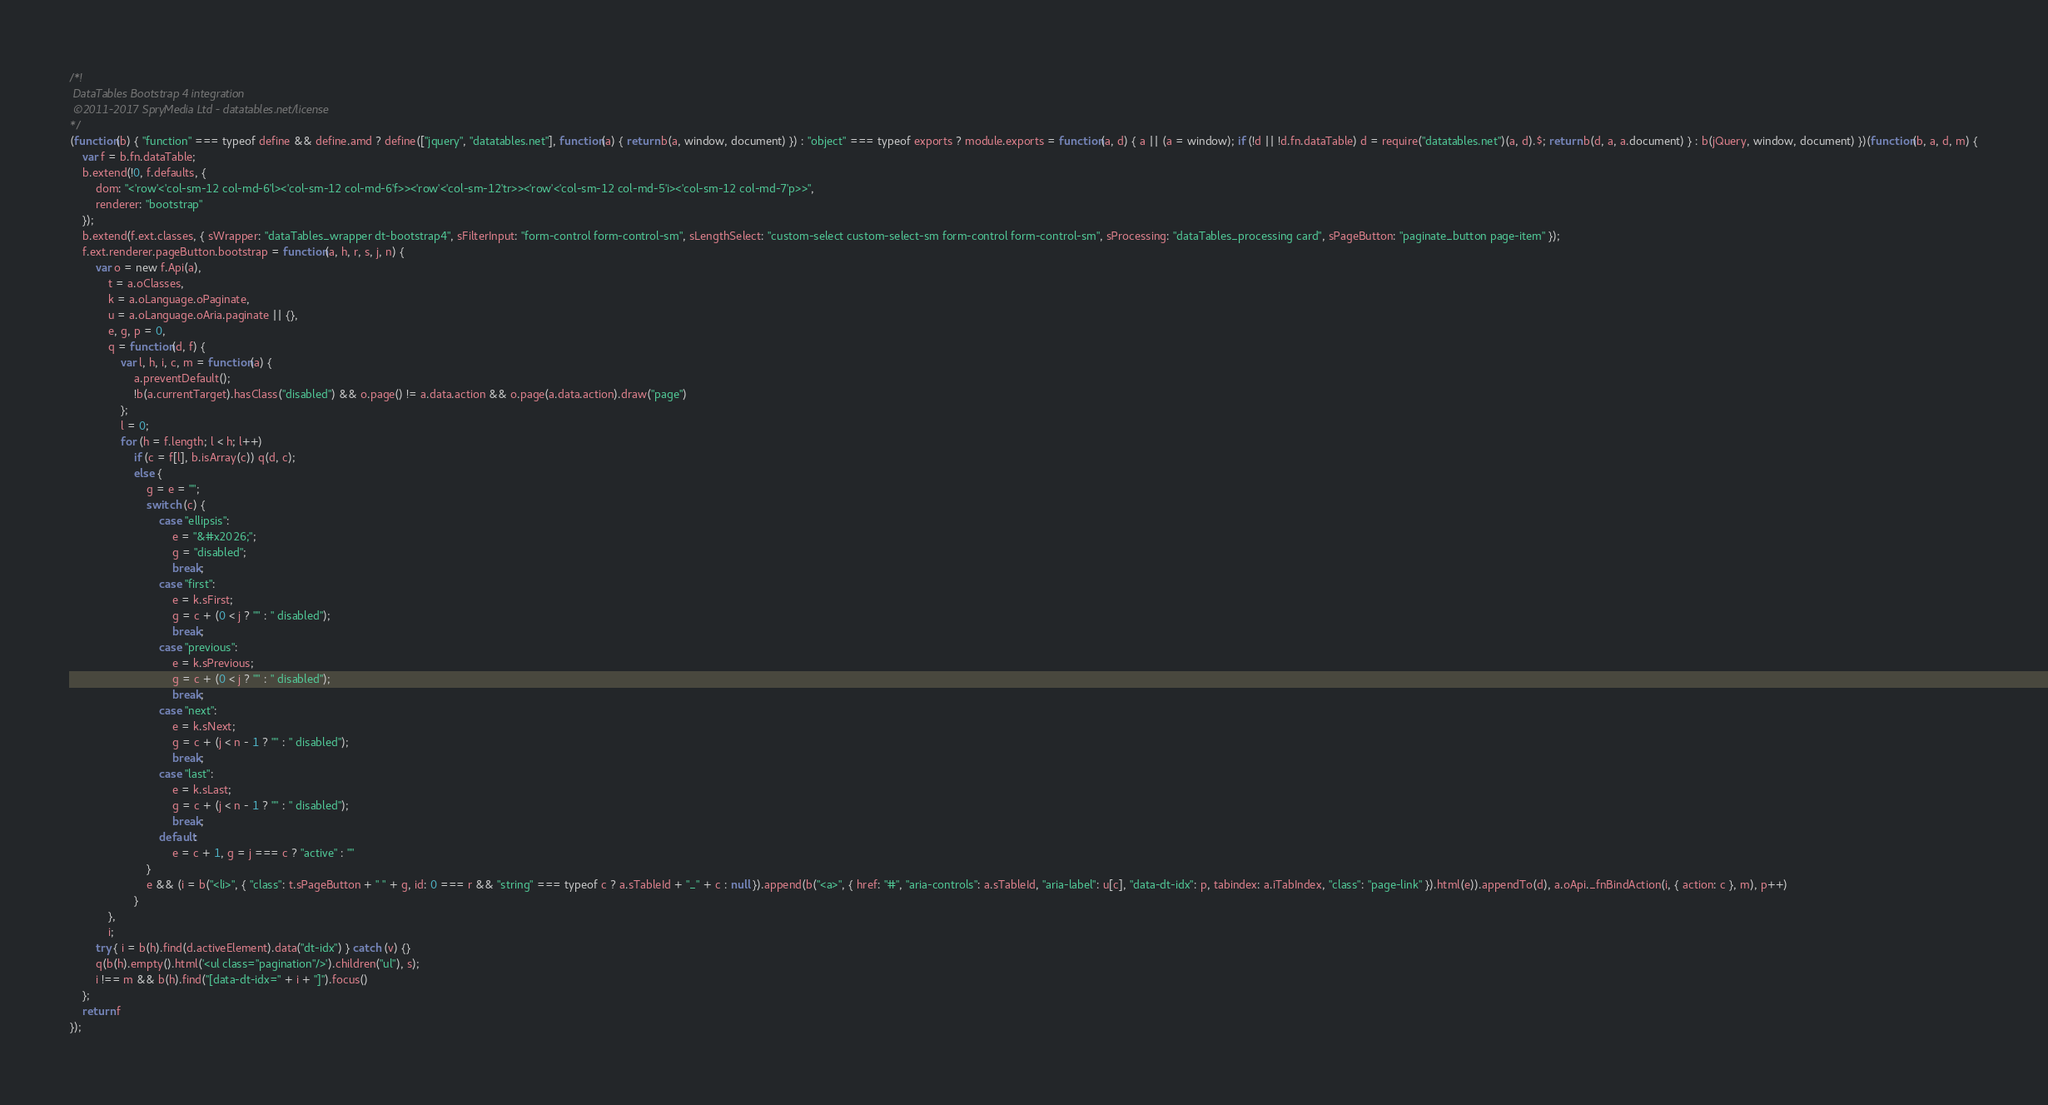<code> <loc_0><loc_0><loc_500><loc_500><_JavaScript_>/*!
 DataTables Bootstrap 4 integration
 ©2011-2017 SpryMedia Ltd - datatables.net/license
*/
(function(b) { "function" === typeof define && define.amd ? define(["jquery", "datatables.net"], function(a) { return b(a, window, document) }) : "object" === typeof exports ? module.exports = function(a, d) { a || (a = window); if (!d || !d.fn.dataTable) d = require("datatables.net")(a, d).$; return b(d, a, a.document) } : b(jQuery, window, document) })(function(b, a, d, m) {
    var f = b.fn.dataTable;
    b.extend(!0, f.defaults, {
        dom: "<'row'<'col-sm-12 col-md-6'l><'col-sm-12 col-md-6'f>><'row'<'col-sm-12'tr>><'row'<'col-sm-12 col-md-5'i><'col-sm-12 col-md-7'p>>",
        renderer: "bootstrap"
    });
    b.extend(f.ext.classes, { sWrapper: "dataTables_wrapper dt-bootstrap4", sFilterInput: "form-control form-control-sm", sLengthSelect: "custom-select custom-select-sm form-control form-control-sm", sProcessing: "dataTables_processing card", sPageButton: "paginate_button page-item" });
    f.ext.renderer.pageButton.bootstrap = function(a, h, r, s, j, n) {
        var o = new f.Api(a),
            t = a.oClasses,
            k = a.oLanguage.oPaginate,
            u = a.oLanguage.oAria.paginate || {},
            e, g, p = 0,
            q = function(d, f) {
                var l, h, i, c, m = function(a) {
                    a.preventDefault();
                    !b(a.currentTarget).hasClass("disabled") && o.page() != a.data.action && o.page(a.data.action).draw("page")
                };
                l = 0;
                for (h = f.length; l < h; l++)
                    if (c = f[l], b.isArray(c)) q(d, c);
                    else {
                        g = e = "";
                        switch (c) {
                            case "ellipsis":
                                e = "&#x2026;";
                                g = "disabled";
                                break;
                            case "first":
                                e = k.sFirst;
                                g = c + (0 < j ? "" : " disabled");
                                break;
                            case "previous":
                                e = k.sPrevious;
                                g = c + (0 < j ? "" : " disabled");
                                break;
                            case "next":
                                e = k.sNext;
                                g = c + (j < n - 1 ? "" : " disabled");
                                break;
                            case "last":
                                e = k.sLast;
                                g = c + (j < n - 1 ? "" : " disabled");
                                break;
                            default:
                                e = c + 1, g = j === c ? "active" : ""
                        }
                        e && (i = b("<li>", { "class": t.sPageButton + " " + g, id: 0 === r && "string" === typeof c ? a.sTableId + "_" + c : null }).append(b("<a>", { href: "#", "aria-controls": a.sTableId, "aria-label": u[c], "data-dt-idx": p, tabindex: a.iTabIndex, "class": "page-link" }).html(e)).appendTo(d), a.oApi._fnBindAction(i, { action: c }, m), p++)
                    }
            },
            i;
        try { i = b(h).find(d.activeElement).data("dt-idx") } catch (v) {}
        q(b(h).empty().html('<ul class="pagination"/>').children("ul"), s);
        i !== m && b(h).find("[data-dt-idx=" + i + "]").focus()
    };
    return f
});</code> 